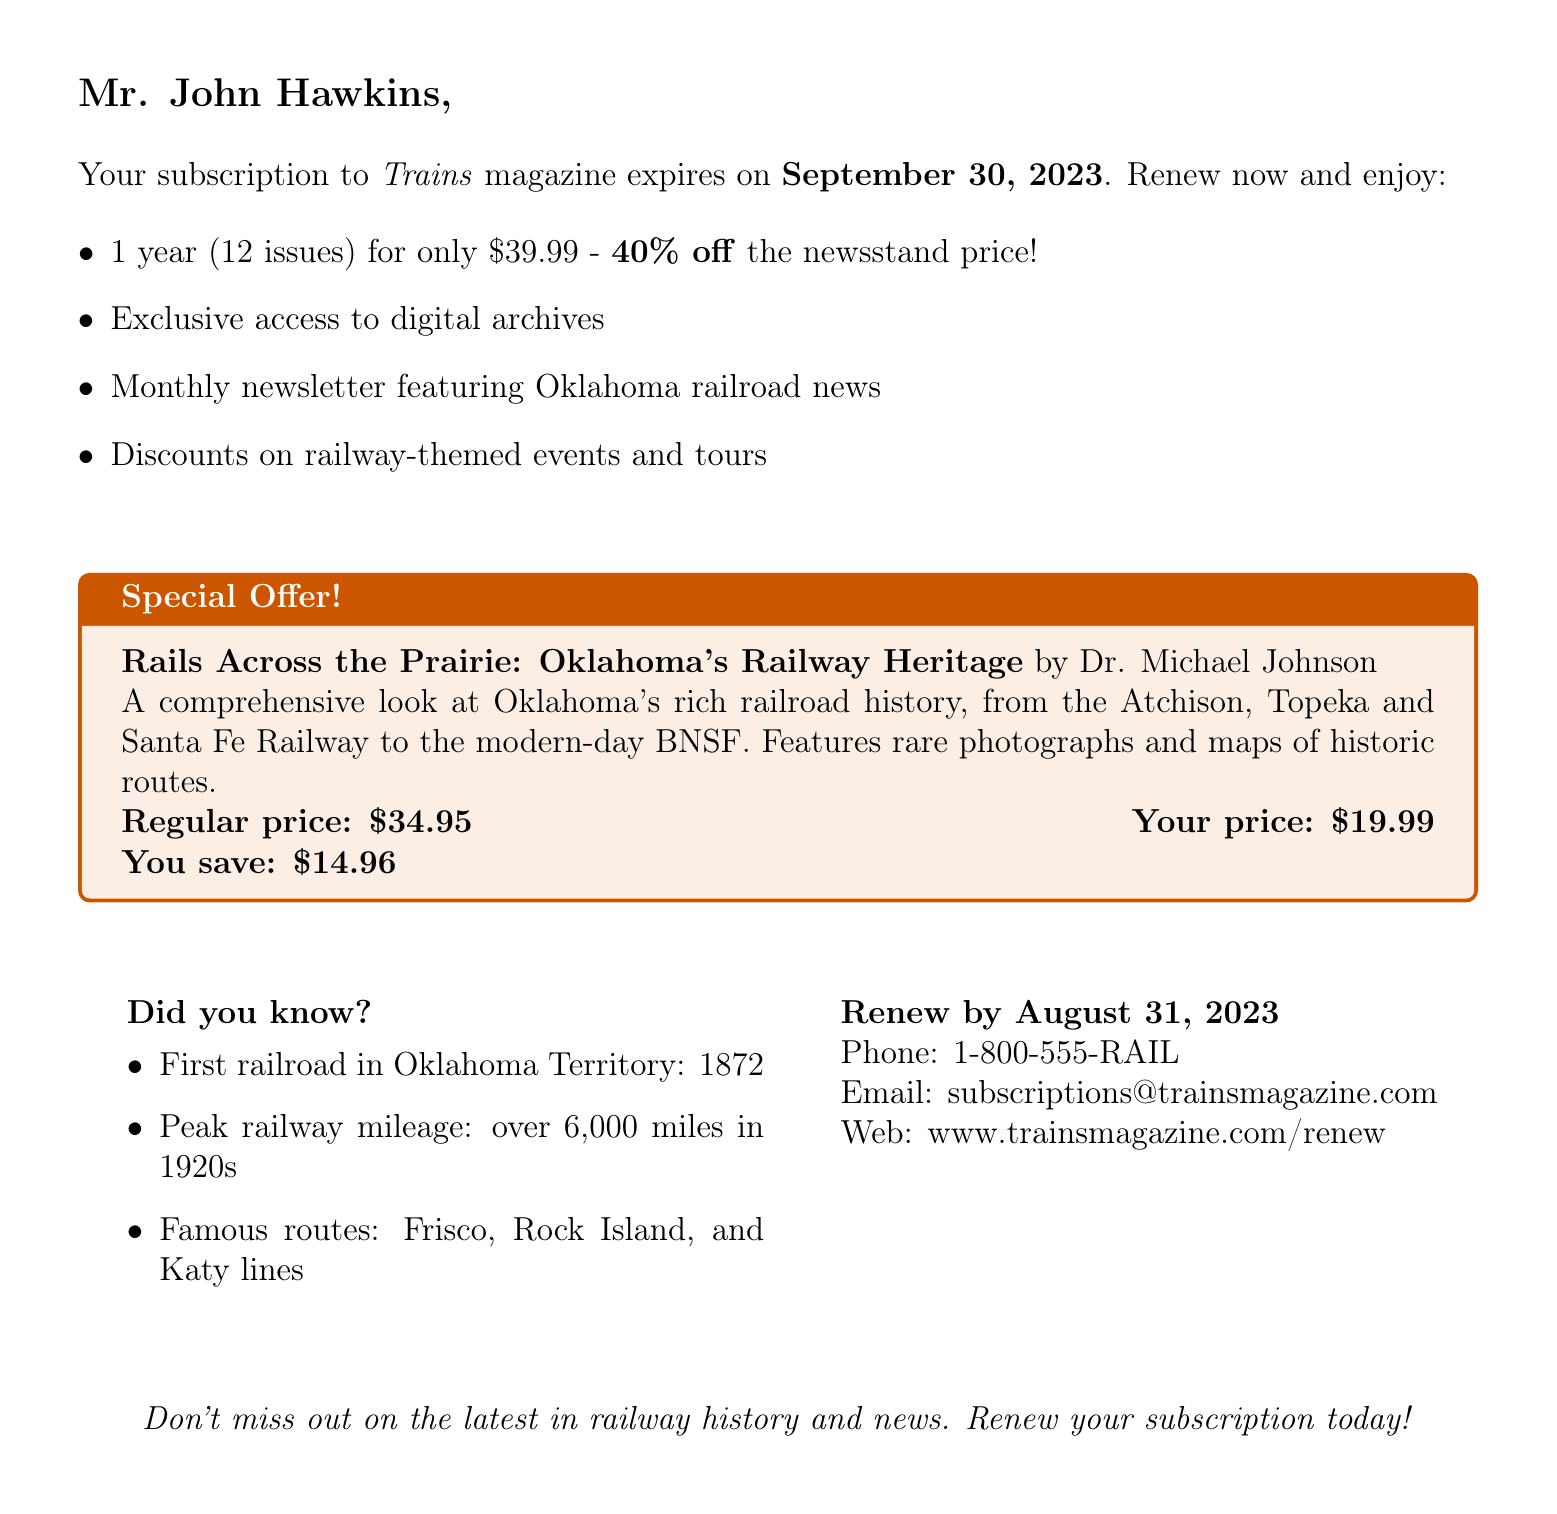What is the name of the magazine? The name of the magazine is mentioned at the top of the document.
Answer: Trains Who is the subscriber? The document addresses a specific person, indicating who the subscriber is.
Answer: Mr. John Hawkins What is the current expiration date of the subscription? The document explicitly states when the current subscription will expire.
Answer: September 30, 2023 What is the special price for the book? The document lists the special price for the book offered in the subscription renewal.
Answer: $19.99 What are the savings on the regular price of the book? The savings on the book are provided in the document as a direct comparison to the regular price.
Answer: $14.96 By what date must the subscription be renewed? The document specifies a deadline for renewing the subscription.
Answer: August 31, 2023 What is included in the renewal benefits? The document lists several benefits that come with the renewal, indicating the value added for subscribers.
Answer: Exclusive access to digital archives What notable fact is mentioned about Oklahoma's railways? The document provides interesting historical facts related to Oklahoma's railways as part of the content.
Answer: First railroad in Oklahoma Territory: 1872 Who is the author of the special offer book? The author's name is mentioned in the special offer section of the document.
Answer: Dr. Michael Johnson 